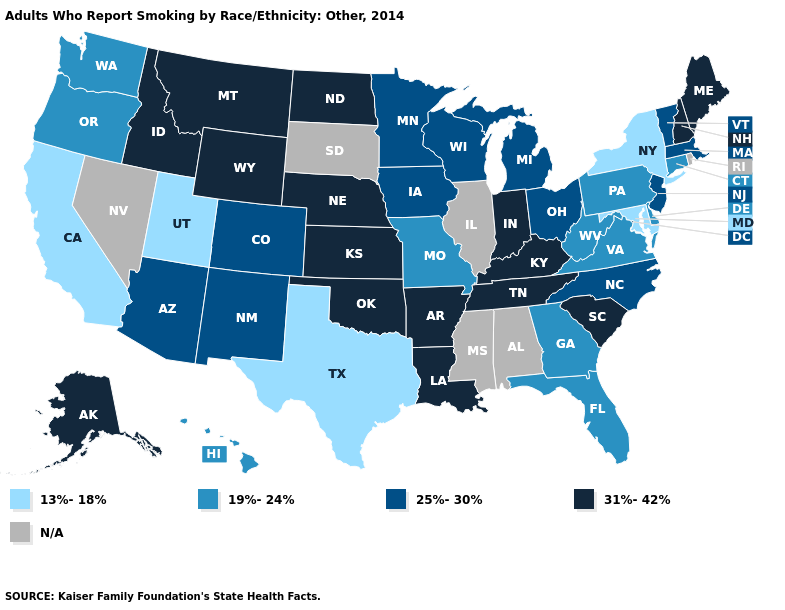Name the states that have a value in the range 25%-30%?
Short answer required. Arizona, Colorado, Iowa, Massachusetts, Michigan, Minnesota, New Jersey, New Mexico, North Carolina, Ohio, Vermont, Wisconsin. What is the value of South Carolina?
Quick response, please. 31%-42%. Which states have the lowest value in the USA?
Write a very short answer. California, Maryland, New York, Texas, Utah. What is the lowest value in the USA?
Short answer required. 13%-18%. What is the value of South Carolina?
Short answer required. 31%-42%. Name the states that have a value in the range 25%-30%?
Keep it brief. Arizona, Colorado, Iowa, Massachusetts, Michigan, Minnesota, New Jersey, New Mexico, North Carolina, Ohio, Vermont, Wisconsin. What is the value of Alabama?
Be succinct. N/A. Which states have the lowest value in the West?
Quick response, please. California, Utah. What is the value of Indiana?
Quick response, please. 31%-42%. Which states have the lowest value in the South?
Answer briefly. Maryland, Texas. Among the states that border New York , which have the highest value?
Be succinct. Massachusetts, New Jersey, Vermont. Does New Hampshire have the highest value in the Northeast?
Concise answer only. Yes. What is the value of Montana?
Be succinct. 31%-42%. Among the states that border Kansas , does Nebraska have the highest value?
Write a very short answer. Yes. 